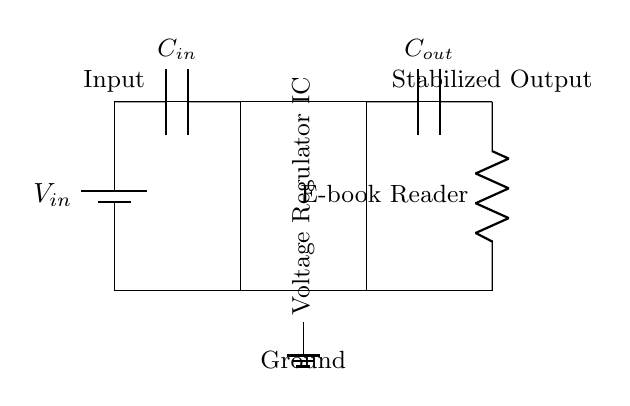What is the input voltage of the circuit? The circuit diagram shows the input voltage labeled as V_in, which represents the supply voltage connected to the circuit.
Answer: V_in What component regulates the voltage? The circuit diagram indicates a rectangle labeled as Voltage Regulator IC, meaning this component is responsible for regulating the output voltage to a stable level.
Answer: Voltage Regulator IC How many capacitors are in the circuit? By counting the components in the diagram, there are two capacitors indicated, labeled as C_in and C_out.
Answer: 2 What is the load connected in this circuit? The output side of the circuit diagram shows a component labeled as E-book Reader, indicating that this is the load that consumes the stabilized output voltage from the regulator.
Answer: E-book Reader What is the purpose of C_in and C_out? The circuit diagram includes capacitors C_in and C_out that are typically used for input filtering and output stability. Therefore, both capacitors serve to stabilize voltage and filter noise.
Answer: Stabilization Why is there a ground connection in this circuit? The ground connection is crucial as it provides a common reference point for all voltages in the circuit, ensuring that all components function correctly and safely. This connection helps manage potential differences and prevents floating voltages.
Answer: Common reference 